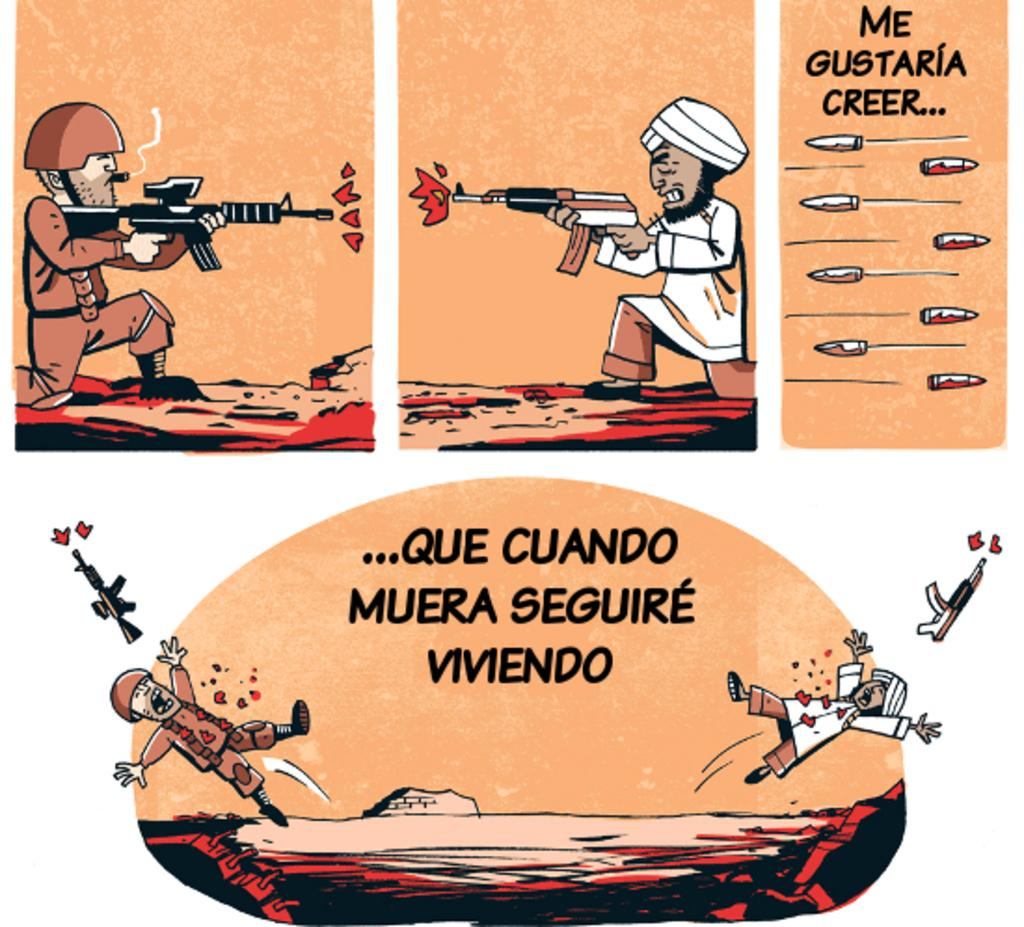What is depicted in the picture? The picture contains animated images of two people. What are the two people doing in the picture? The two people are firing at each other. How many sponges can be seen in the picture? There are no sponges present in the picture. What type of bikes are the two people riding in the picture? There are no bikes present in the picture; the two people are animated images firing at each other. 